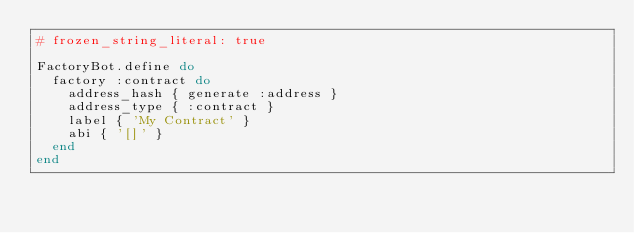Convert code to text. <code><loc_0><loc_0><loc_500><loc_500><_Ruby_># frozen_string_literal: true

FactoryBot.define do
  factory :contract do
    address_hash { generate :address }
    address_type { :contract }
    label { 'My Contract' }
    abi { '[]' }
  end
end
</code> 